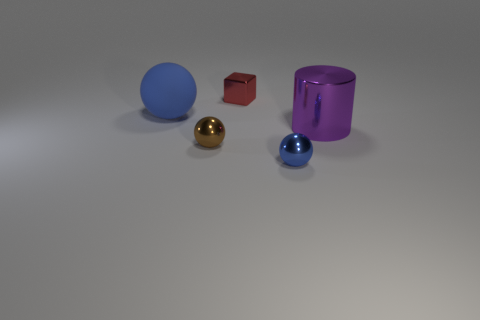There is a big blue object that is the same shape as the brown metallic object; what is its material?
Keep it short and to the point. Rubber. There is another small sphere that is the same color as the matte ball; what is it made of?
Offer a very short reply. Metal. There is a brown thing that is the same size as the red shiny object; what is it made of?
Your answer should be compact. Metal. What number of small objects are brown metal things or shiny objects?
Offer a terse response. 3. What number of things are objects in front of the big blue object or purple cylinders that are right of the brown ball?
Your answer should be compact. 3. Is the number of large balls less than the number of large green matte objects?
Provide a short and direct response. No. The purple metallic object that is the same size as the blue matte thing is what shape?
Provide a short and direct response. Cylinder. What number of other objects are the same color as the large metallic cylinder?
Your answer should be very brief. 0. How many brown metal things are there?
Provide a short and direct response. 1. What number of objects are to the left of the purple cylinder and in front of the big blue sphere?
Keep it short and to the point. 2. 